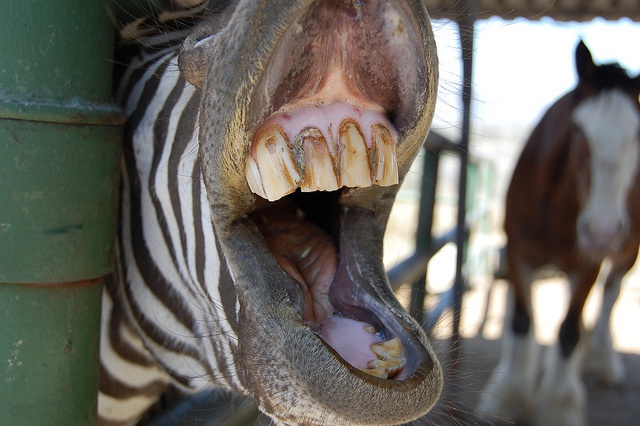Describe the objects in this image and their specific colors. I can see zebra in teal, gray, black, and darkgray tones and horse in teal, black, and gray tones in this image. 